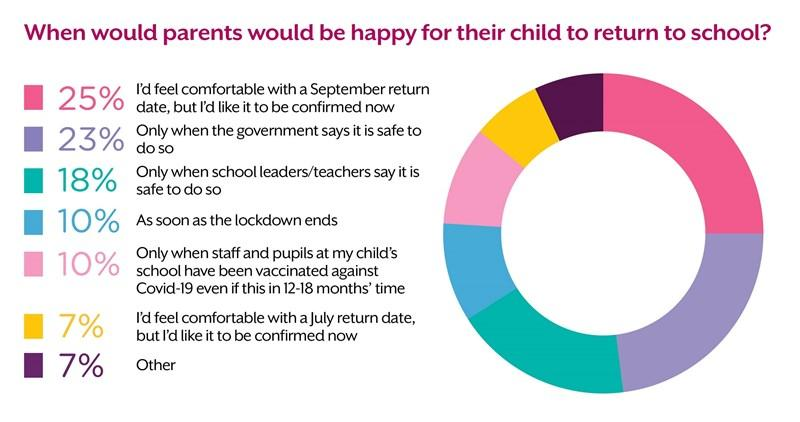Identify some key points in this picture. The phrase "By which people are the parents highlighted in yellow colour comfortable as the return date? July.." is a question that requires a more specific context to understand its intended meaning. However, assuming that the question is asking about the comfort of parents who have a child with a return date of July, the sentence could be rephrased as:

"Will parents be comfortable with their child's return date being July? According to the survey, 41% of respondents are prepared to send their children to school when school leaders or the government declare it safe, despite any concerns they may have. A majority of parents believe that their children can return home as soon as the lockdown ends or when the staff and pupils at their child's school have been vaccinated against COVID-19, according to a recent survey.  According to the survey, only 10% of parents are willing to wait for 12-18 months for the next generation of smartphones. 